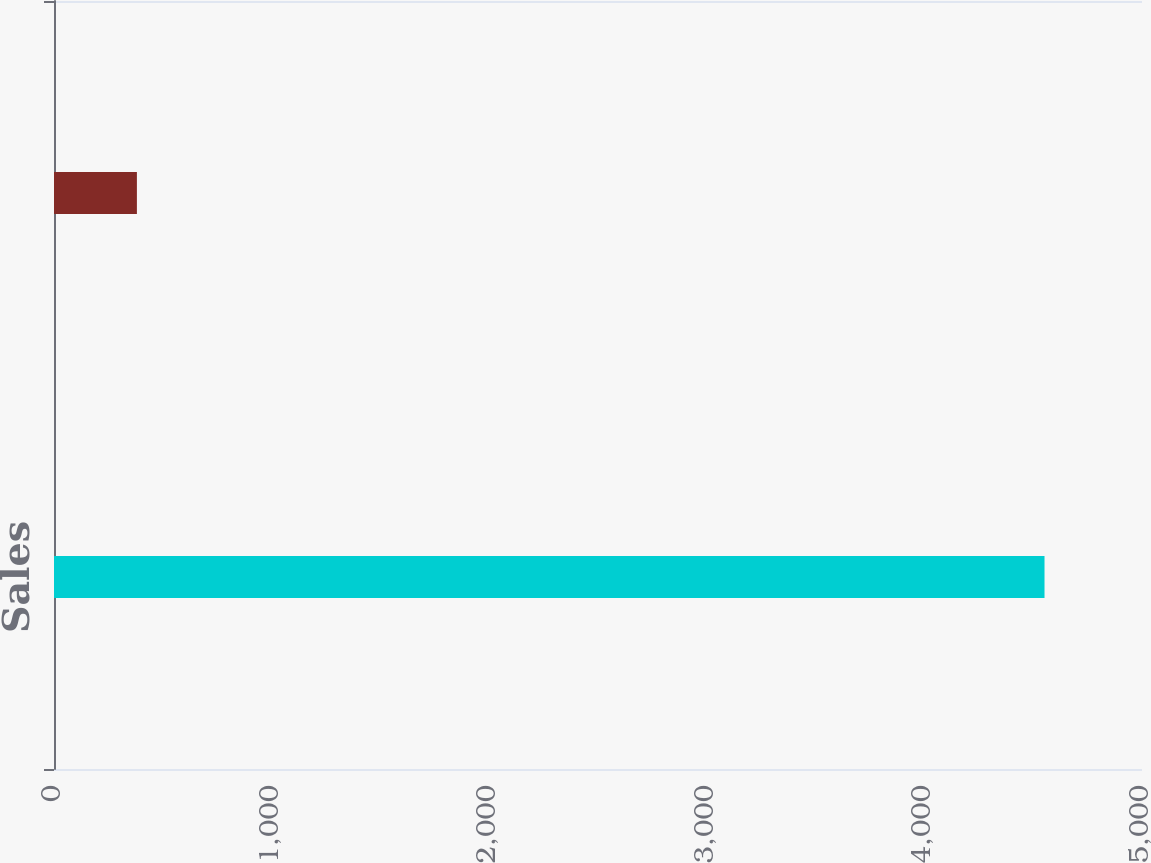<chart> <loc_0><loc_0><loc_500><loc_500><bar_chart><fcel>Sales<fcel>Operating Income<nl><fcel>4552<fcel>381<nl></chart> 